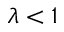<formula> <loc_0><loc_0><loc_500><loc_500>\lambda < 1</formula> 